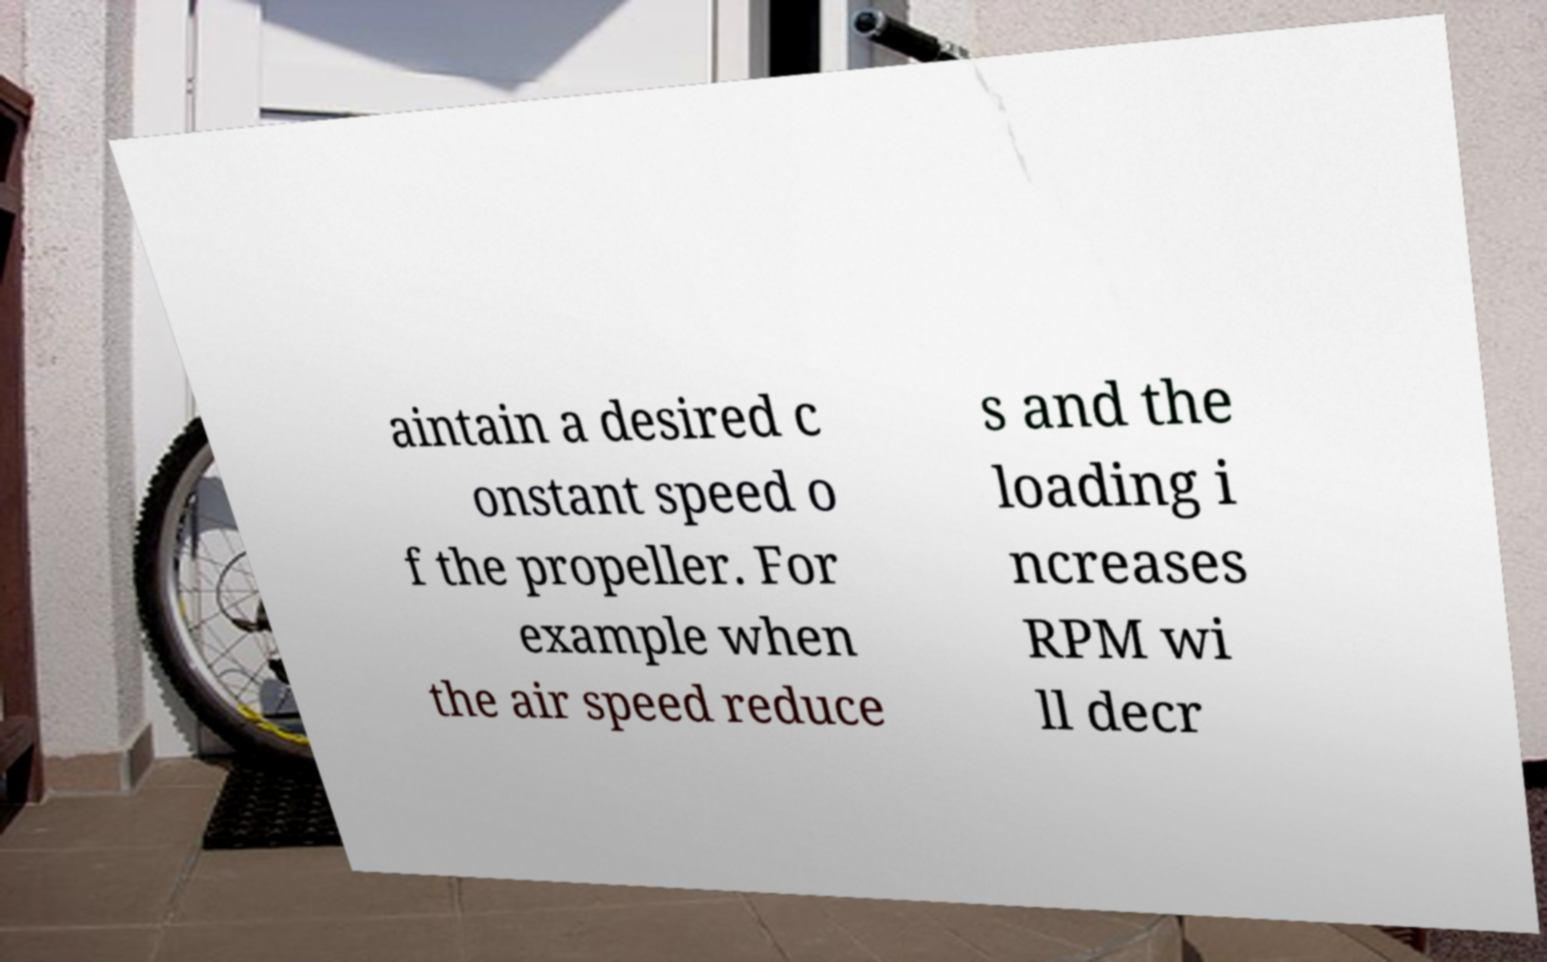Could you assist in decoding the text presented in this image and type it out clearly? aintain a desired c onstant speed o f the propeller. For example when the air speed reduce s and the loading i ncreases RPM wi ll decr 